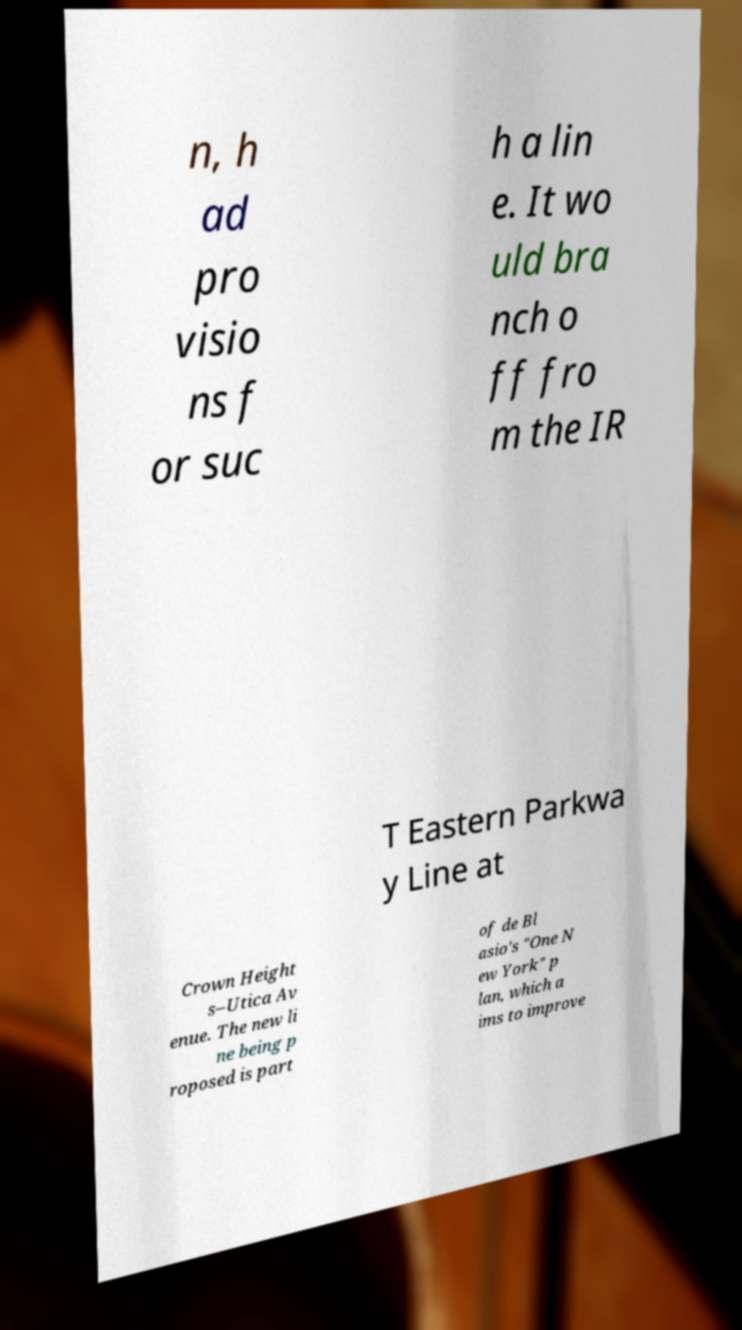There's text embedded in this image that I need extracted. Can you transcribe it verbatim? n, h ad pro visio ns f or suc h a lin e. It wo uld bra nch o ff fro m the IR T Eastern Parkwa y Line at Crown Height s–Utica Av enue. The new li ne being p roposed is part of de Bl asio's "One N ew York" p lan, which a ims to improve 